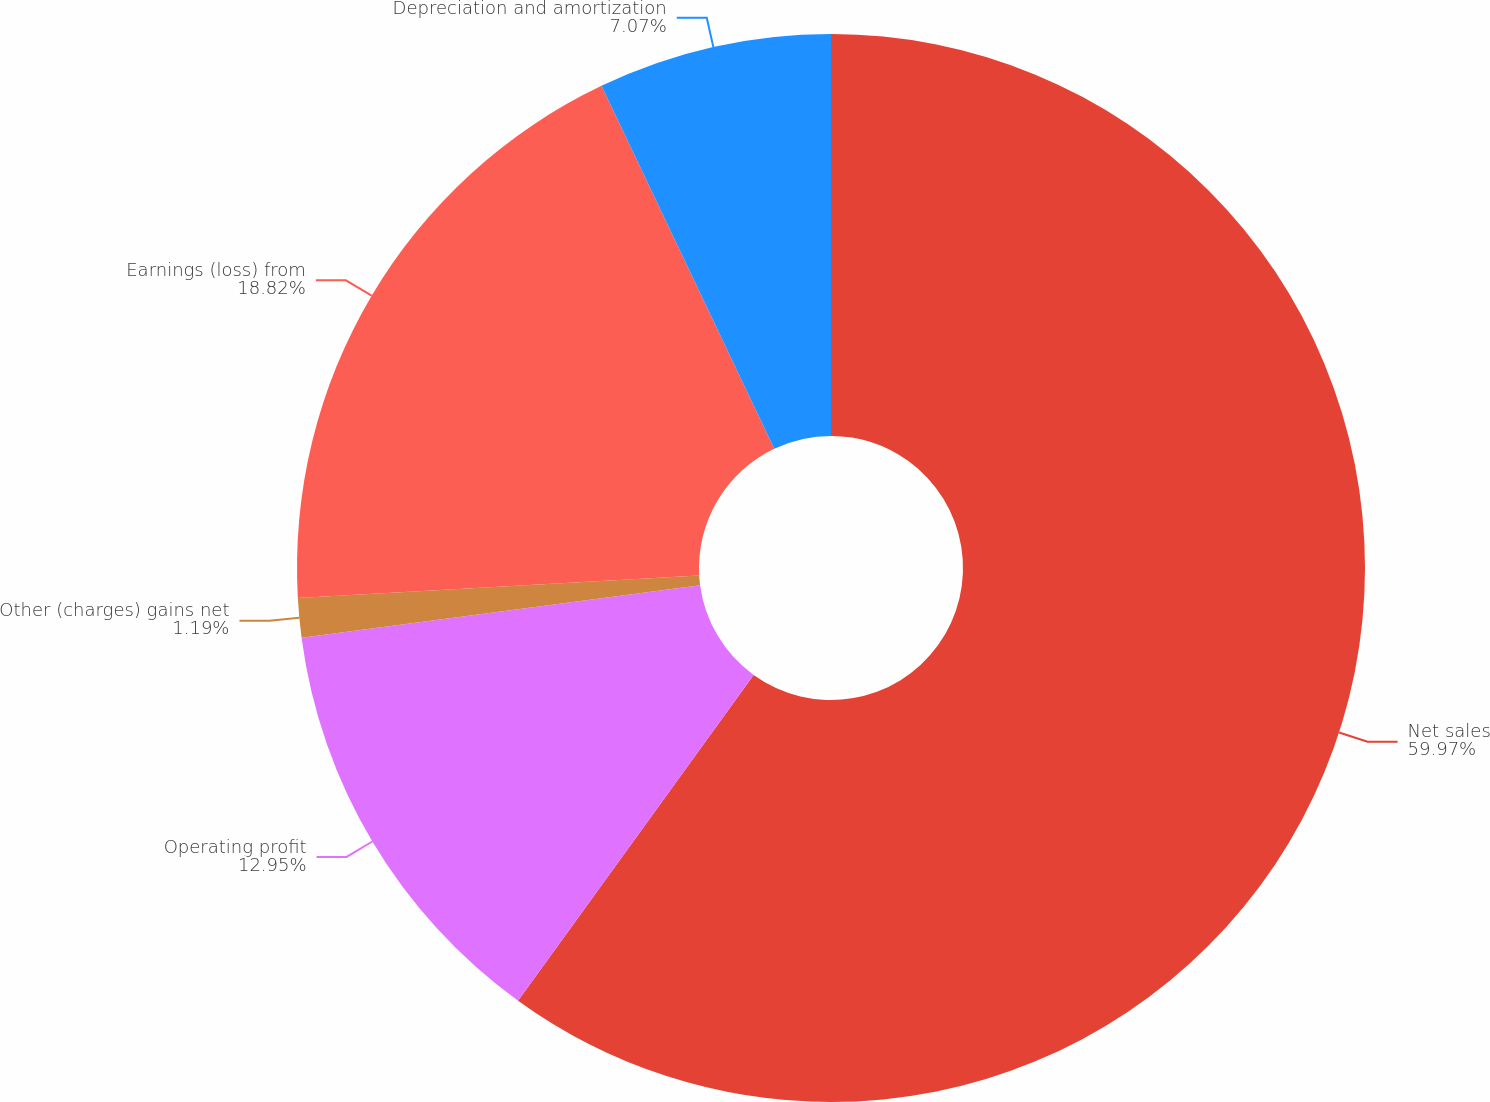<chart> <loc_0><loc_0><loc_500><loc_500><pie_chart><fcel>Net sales<fcel>Operating profit<fcel>Other (charges) gains net<fcel>Earnings (loss) from<fcel>Depreciation and amortization<nl><fcel>59.96%<fcel>12.95%<fcel>1.19%<fcel>18.82%<fcel>7.07%<nl></chart> 